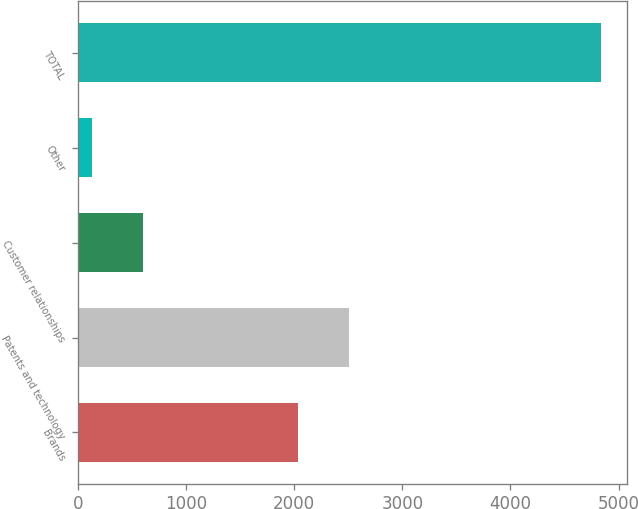Convert chart. <chart><loc_0><loc_0><loc_500><loc_500><bar_chart><fcel>Brands<fcel>Patents and technology<fcel>Customer relationships<fcel>Other<fcel>TOTAL<nl><fcel>2032<fcel>2503<fcel>601<fcel>130<fcel>4840<nl></chart> 